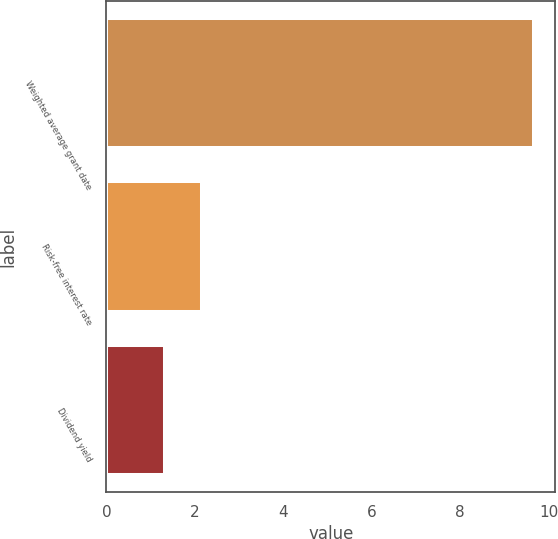Convert chart. <chart><loc_0><loc_0><loc_500><loc_500><bar_chart><fcel>Weighted average grant date<fcel>Risk-free interest rate<fcel>Dividend yield<nl><fcel>9.67<fcel>2.16<fcel>1.32<nl></chart> 